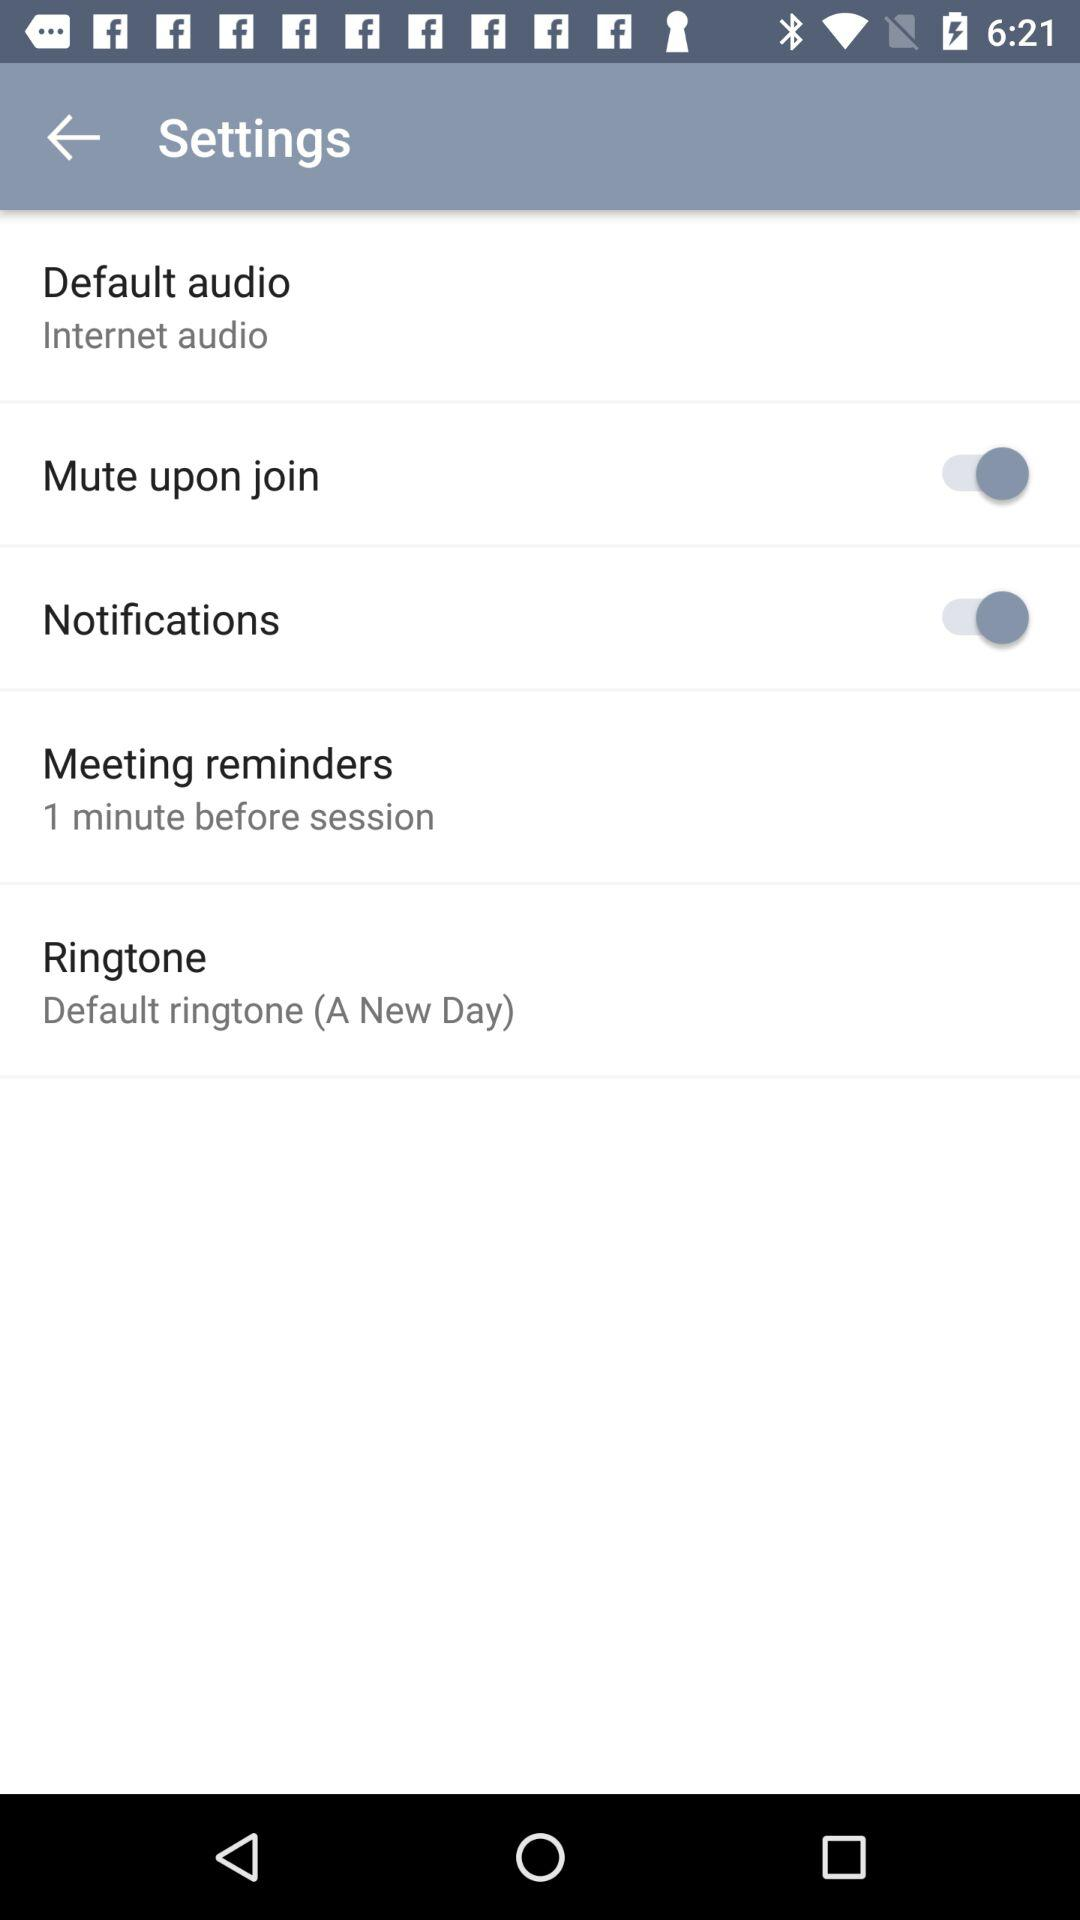What is the set ringtone? The set ringtone is the default ringtone (A New Day). 